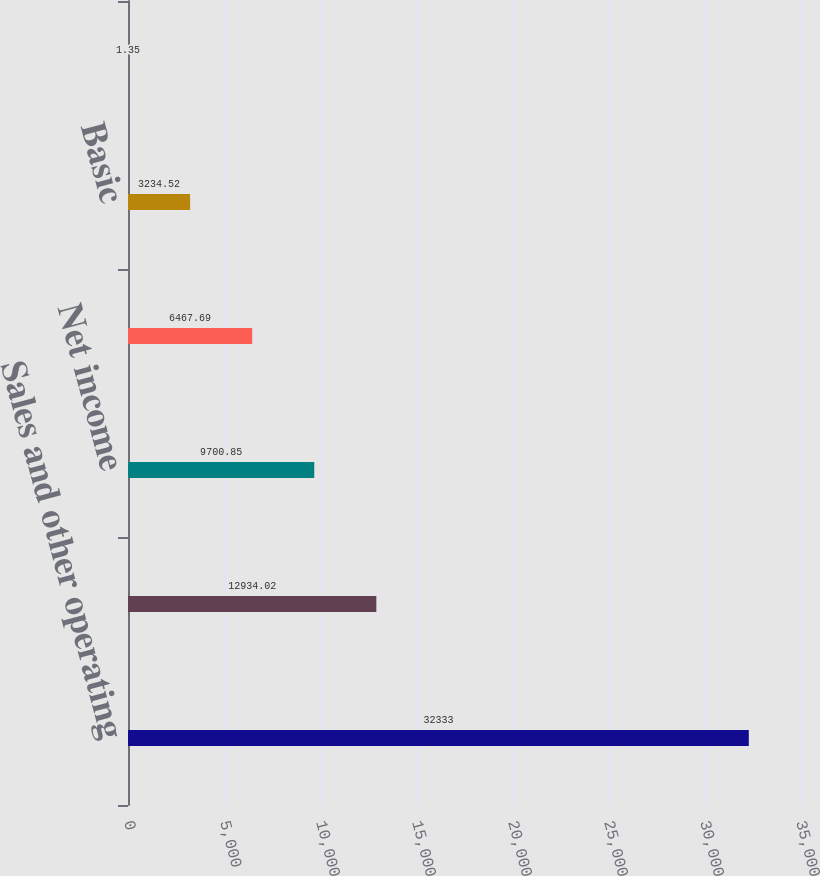Convert chart. <chart><loc_0><loc_0><loc_500><loc_500><bar_chart><fcel>Sales and other operating<fcel>Income from operations<fcel>Net income<fcel>Net income attributable to MPC<fcel>Basic<fcel>Diluted<nl><fcel>32333<fcel>12934<fcel>9700.85<fcel>6467.69<fcel>3234.52<fcel>1.35<nl></chart> 